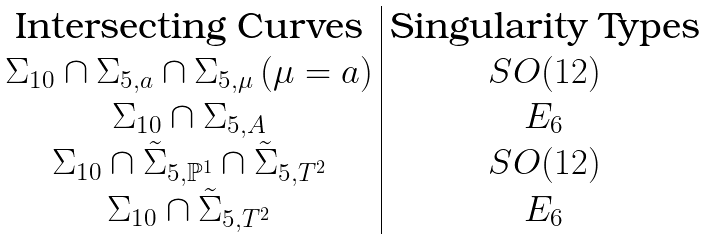<formula> <loc_0><loc_0><loc_500><loc_500>\begin{array} { c | c } \text {Intersecting Curves} & \text {Singularity Types} \\ \Sigma _ { 1 0 } \cap \Sigma _ { 5 , a } \cap \Sigma _ { 5 , \mu } \, ( \mu = a ) & S O ( 1 2 ) \\ \Sigma _ { 1 0 } \cap \Sigma _ { 5 , A } & E _ { 6 } \\ \Sigma _ { 1 0 } \cap \tilde { \Sigma } _ { 5 , \mathbb { P } ^ { 1 } } \cap \tilde { \Sigma } _ { 5 , T ^ { 2 } } & S O ( 1 2 ) \\ \Sigma _ { 1 0 } \cap \tilde { \Sigma } _ { 5 , T ^ { 2 } } & E _ { 6 } \end{array}</formula> 